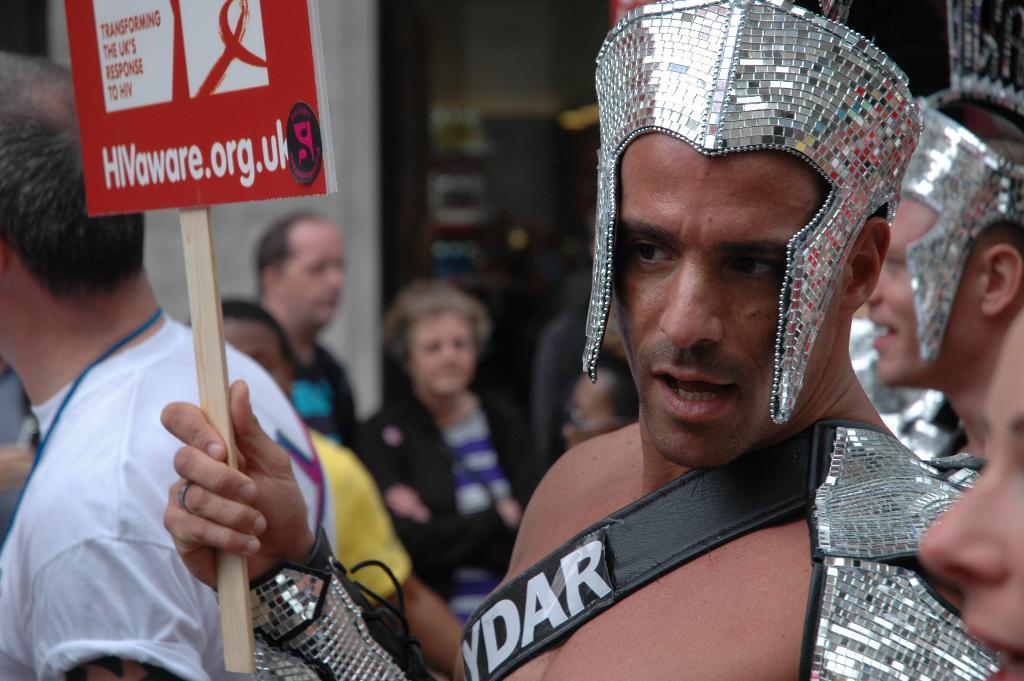What is the man in the image holding? The man is holding a poster in the image. Can you describe the people in the image? There are people in the image, but their specific characteristics are not mentioned in the facts. What can be seen in the background of the image? The background of the image contains some objects, but their specific details are not mentioned in the facts. How would you describe the background of the image? The background is blurry. What type of arithmetic problem is being solved by the people in the image? There is no arithmetic problem being solved in the image; it only shows a man holding a poster and people in the background. What kind of berry is being held by the man in the image? There is no berry present in the image; the man is holding a poster. 